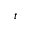Convert formula to latex. <formula><loc_0><loc_0><loc_500><loc_500>t</formula> 